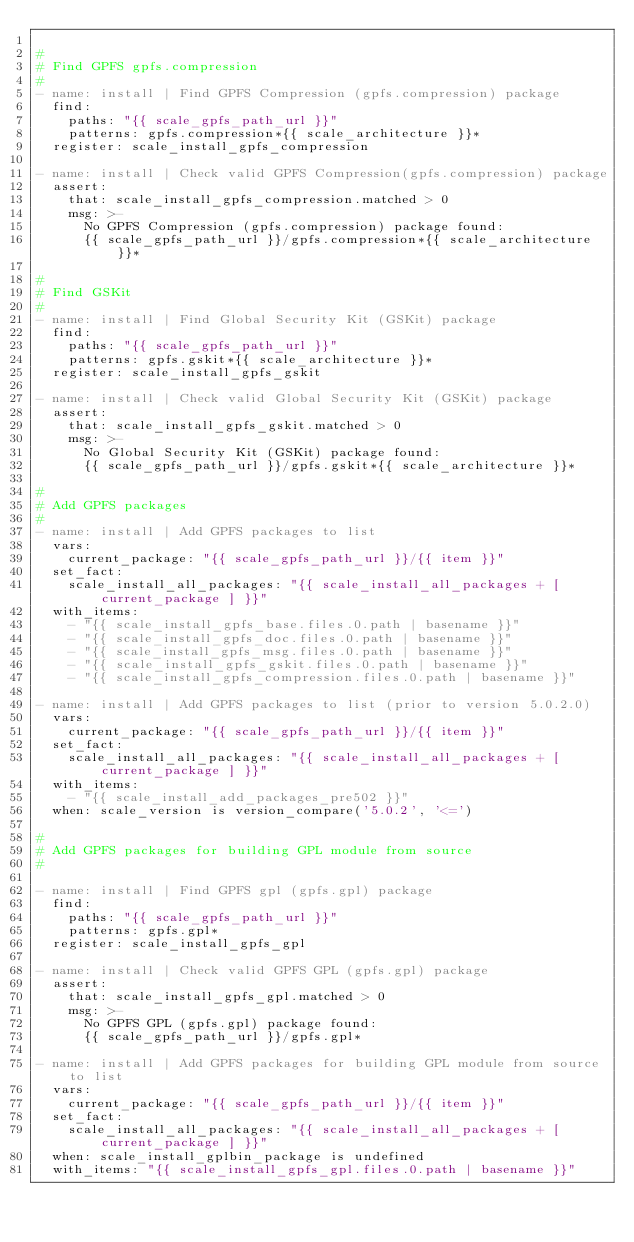Convert code to text. <code><loc_0><loc_0><loc_500><loc_500><_YAML_>
#
# Find GPFS gpfs.compression
#
- name: install | Find GPFS Compression (gpfs.compression) package
  find:
    paths: "{{ scale_gpfs_path_url }}"
    patterns: gpfs.compression*{{ scale_architecture }}*
  register: scale_install_gpfs_compression

- name: install | Check valid GPFS Compression(gpfs.compression) package
  assert:
    that: scale_install_gpfs_compression.matched > 0
    msg: >-
      No GPFS Compression (gpfs.compression) package found:
      {{ scale_gpfs_path_url }}/gpfs.compression*{{ scale_architecture }}*

#
# Find GSKit
#
- name: install | Find Global Security Kit (GSKit) package
  find:
    paths: "{{ scale_gpfs_path_url }}"
    patterns: gpfs.gskit*{{ scale_architecture }}*
  register: scale_install_gpfs_gskit

- name: install | Check valid Global Security Kit (GSKit) package
  assert:
    that: scale_install_gpfs_gskit.matched > 0
    msg: >-
      No Global Security Kit (GSKit) package found:
      {{ scale_gpfs_path_url }}/gpfs.gskit*{{ scale_architecture }}*

#
# Add GPFS packages
#
- name: install | Add GPFS packages to list
  vars:
    current_package: "{{ scale_gpfs_path_url }}/{{ item }}"
  set_fact:
    scale_install_all_packages: "{{ scale_install_all_packages + [ current_package ] }}"
  with_items:
    - "{{ scale_install_gpfs_base.files.0.path | basename }}"
    - "{{ scale_install_gpfs_doc.files.0.path | basename }}"
    - "{{ scale_install_gpfs_msg.files.0.path | basename }}"
    - "{{ scale_install_gpfs_gskit.files.0.path | basename }}"
    - "{{ scale_install_gpfs_compression.files.0.path | basename }}"

- name: install | Add GPFS packages to list (prior to version 5.0.2.0)
  vars:
    current_package: "{{ scale_gpfs_path_url }}/{{ item }}"
  set_fact:
    scale_install_all_packages: "{{ scale_install_all_packages + [ current_package ] }}"
  with_items:
    - "{{ scale_install_add_packages_pre502 }}"
  when: scale_version is version_compare('5.0.2', '<=')

#
# Add GPFS packages for building GPL module from source
#

- name: install | Find GPFS gpl (gpfs.gpl) package
  find:
    paths: "{{ scale_gpfs_path_url }}"
    patterns: gpfs.gpl*
  register: scale_install_gpfs_gpl

- name: install | Check valid GPFS GPL (gpfs.gpl) package
  assert:
    that: scale_install_gpfs_gpl.matched > 0
    msg: >-
      No GPFS GPL (gpfs.gpl) package found:
      {{ scale_gpfs_path_url }}/gpfs.gpl*

- name: install | Add GPFS packages for building GPL module from source to list
  vars:
    current_package: "{{ scale_gpfs_path_url }}/{{ item }}"
  set_fact:
    scale_install_all_packages: "{{ scale_install_all_packages + [ current_package ] }}"
  when: scale_install_gplbin_package is undefined
  with_items: "{{ scale_install_gpfs_gpl.files.0.path | basename }}"
</code> 